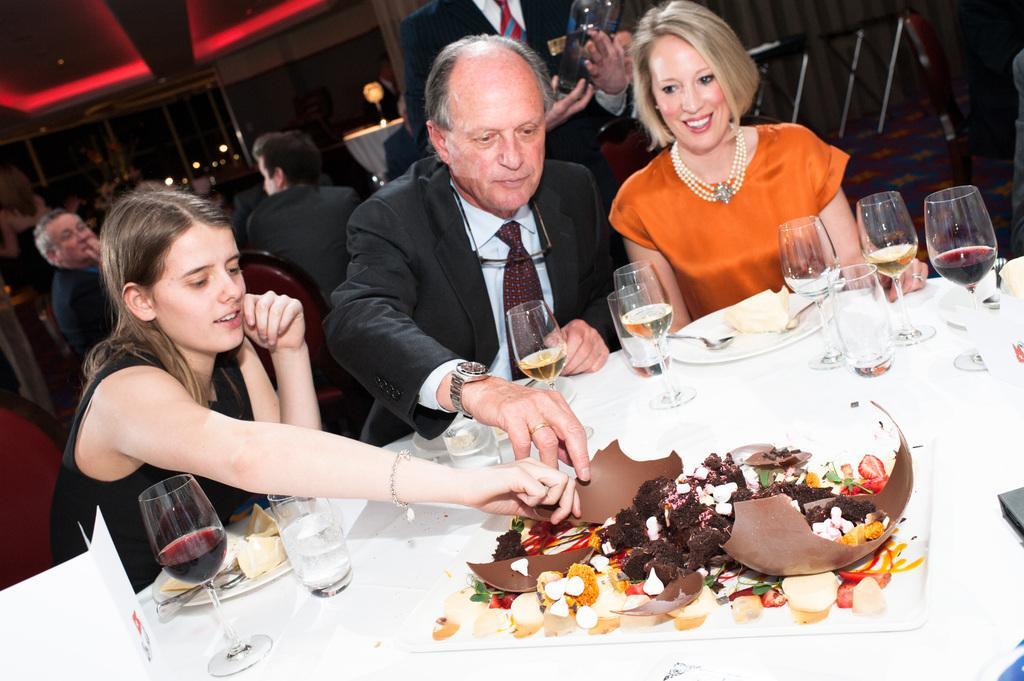Describe this image in one or two sentences. In this picture we can see a man and a woman holding a food item in their hands. We can see a person sitting on the right side. There are a few food items visible on a white surface. We can see the liquid in a few glasses. There are plates, spoons, card and other objects are visible on the table. We can see a person holding a bottle at the back. We can see a few people, rods, lights and other objects in the background. 